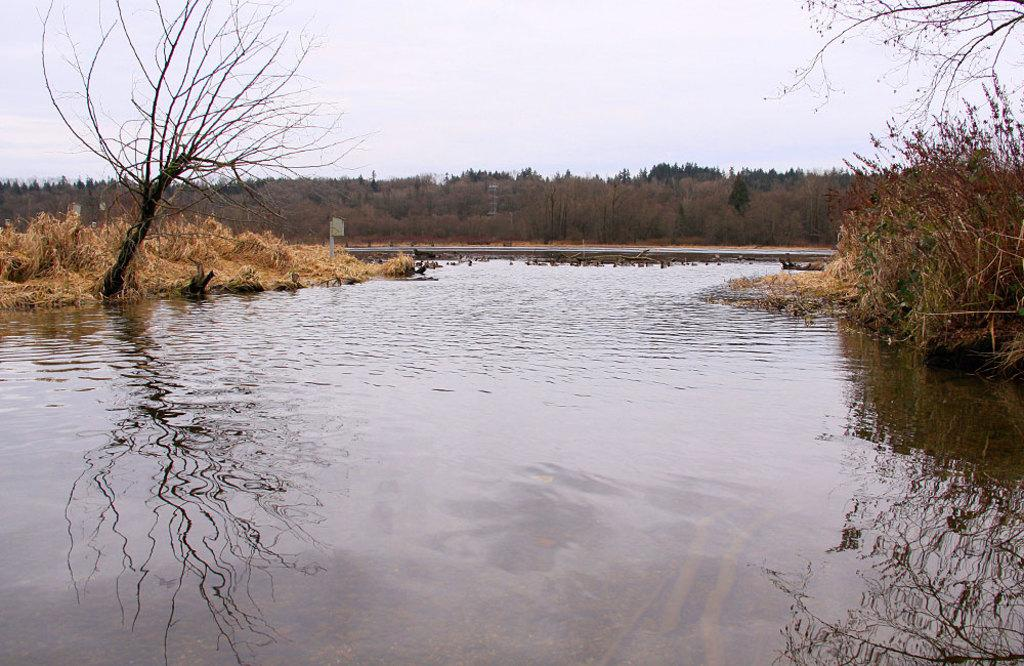What type of view is shown in the image? The image is an outside view. What natural feature can be seen at the bottom of the image? There is a river at the bottom of the image. What type of vegetation is visible in the background of the image? There are many trees in the background of the image. What is visible at the top of the image? The sky is visible at the top of the image. How many jellyfish can be seen swimming in the river in the image? There are no jellyfish present in the image; it features a river with trees and sky in the background. What type of request is being made in the image? There is no request being made in the image; it is a still image of an outdoor scene. 